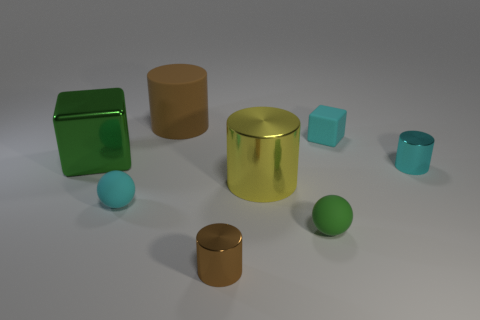How many other things are the same size as the cyan rubber block?
Your response must be concise. 4. What is the cube that is on the right side of the tiny sphere in front of the matte sphere that is behind the green sphere made of?
Offer a very short reply. Rubber. How many cylinders are either small green things or small brown metallic things?
Offer a very short reply. 1. Is the number of tiny cyan shiny things that are on the left side of the brown metal object greater than the number of brown metal things that are behind the small cyan cube?
Make the answer very short. No. How many big green metal things are on the left side of the green thing behind the small cyan sphere?
Offer a terse response. 0. What number of things are green metal things or cyan balls?
Give a very brief answer. 2. Does the large green object have the same shape as the yellow metallic object?
Make the answer very short. No. What material is the tiny cyan sphere?
Provide a short and direct response. Rubber. How many shiny objects are both to the left of the large yellow metallic cylinder and to the right of the big metallic cube?
Your answer should be compact. 1. Do the yellow cylinder and the cyan ball have the same size?
Provide a short and direct response. No. 